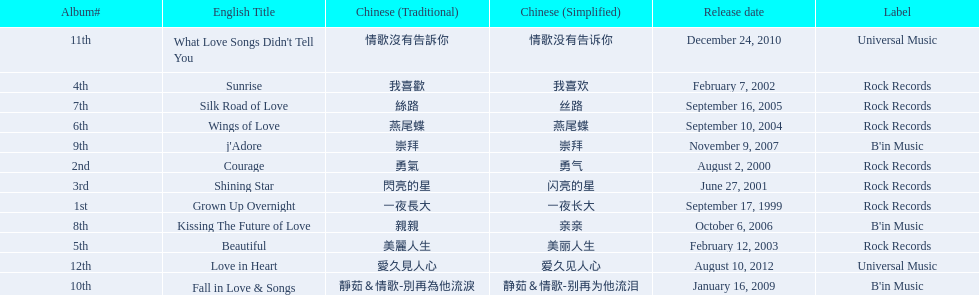Which english titles were released during even years? Courage, Sunrise, Silk Road of Love, Kissing The Future of Love, What Love Songs Didn't Tell You, Love in Heart. Out of the following, which one was released under b's in music? Kissing The Future of Love. 